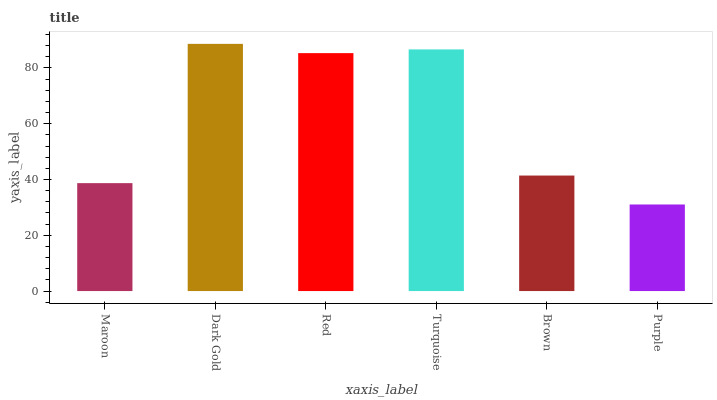Is Purple the minimum?
Answer yes or no. Yes. Is Dark Gold the maximum?
Answer yes or no. Yes. Is Red the minimum?
Answer yes or no. No. Is Red the maximum?
Answer yes or no. No. Is Dark Gold greater than Red?
Answer yes or no. Yes. Is Red less than Dark Gold?
Answer yes or no. Yes. Is Red greater than Dark Gold?
Answer yes or no. No. Is Dark Gold less than Red?
Answer yes or no. No. Is Red the high median?
Answer yes or no. Yes. Is Brown the low median?
Answer yes or no. Yes. Is Dark Gold the high median?
Answer yes or no. No. Is Turquoise the low median?
Answer yes or no. No. 